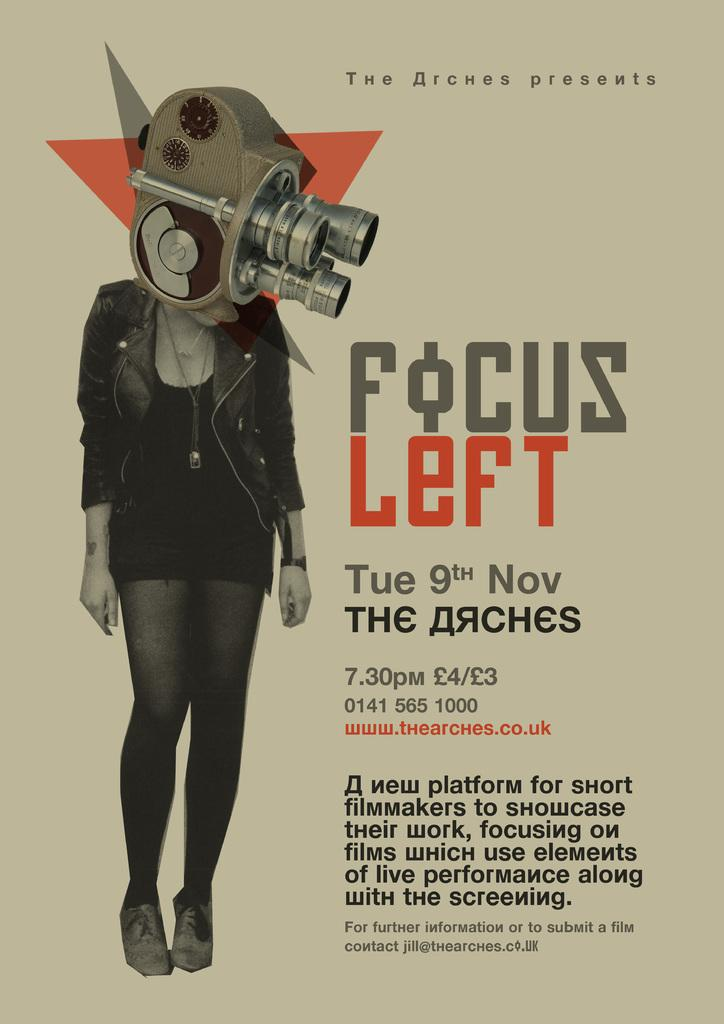<image>
Write a terse but informative summary of the picture. A poster advertises Focus Left, coming on Tuesday November 9th. 